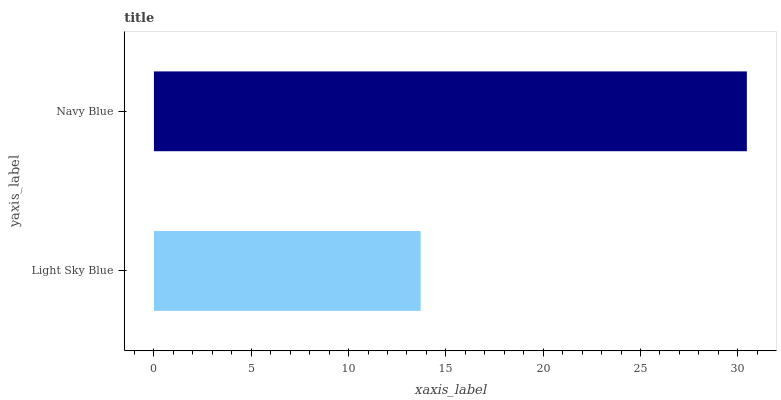Is Light Sky Blue the minimum?
Answer yes or no. Yes. Is Navy Blue the maximum?
Answer yes or no. Yes. Is Navy Blue the minimum?
Answer yes or no. No. Is Navy Blue greater than Light Sky Blue?
Answer yes or no. Yes. Is Light Sky Blue less than Navy Blue?
Answer yes or no. Yes. Is Light Sky Blue greater than Navy Blue?
Answer yes or no. No. Is Navy Blue less than Light Sky Blue?
Answer yes or no. No. Is Navy Blue the high median?
Answer yes or no. Yes. Is Light Sky Blue the low median?
Answer yes or no. Yes. Is Light Sky Blue the high median?
Answer yes or no. No. Is Navy Blue the low median?
Answer yes or no. No. 